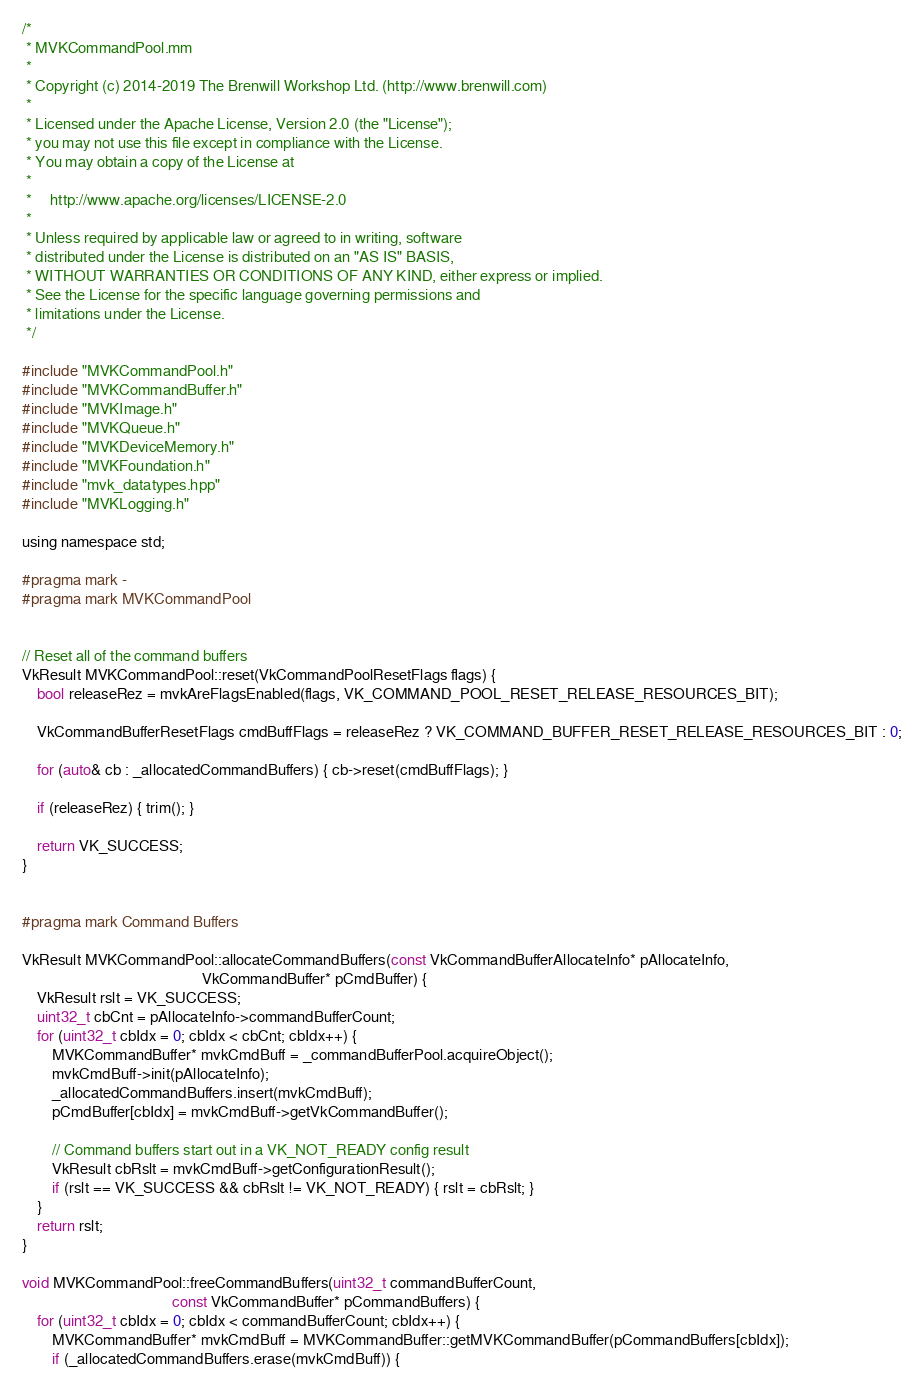<code> <loc_0><loc_0><loc_500><loc_500><_ObjectiveC_>/*
 * MVKCommandPool.mm
 *
 * Copyright (c) 2014-2019 The Brenwill Workshop Ltd. (http://www.brenwill.com)
 *
 * Licensed under the Apache License, Version 2.0 (the "License");
 * you may not use this file except in compliance with the License.
 * You may obtain a copy of the License at
 * 
 *     http://www.apache.org/licenses/LICENSE-2.0
 * 
 * Unless required by applicable law or agreed to in writing, software
 * distributed under the License is distributed on an "AS IS" BASIS,
 * WITHOUT WARRANTIES OR CONDITIONS OF ANY KIND, either express or implied.
 * See the License for the specific language governing permissions and
 * limitations under the License.
 */

#include "MVKCommandPool.h"
#include "MVKCommandBuffer.h"
#include "MVKImage.h"
#include "MVKQueue.h"
#include "MVKDeviceMemory.h"
#include "MVKFoundation.h"
#include "mvk_datatypes.hpp"
#include "MVKLogging.h"

using namespace std;

#pragma mark -
#pragma mark MVKCommandPool


// Reset all of the command buffers
VkResult MVKCommandPool::reset(VkCommandPoolResetFlags flags) {
	bool releaseRez = mvkAreFlagsEnabled(flags, VK_COMMAND_POOL_RESET_RELEASE_RESOURCES_BIT);

	VkCommandBufferResetFlags cmdBuffFlags = releaseRez ? VK_COMMAND_BUFFER_RESET_RELEASE_RESOURCES_BIT : 0;

	for (auto& cb : _allocatedCommandBuffers) { cb->reset(cmdBuffFlags); }

	if (releaseRez) { trim(); }

	return VK_SUCCESS;
}


#pragma mark Command Buffers

VkResult MVKCommandPool::allocateCommandBuffers(const VkCommandBufferAllocateInfo* pAllocateInfo,
												VkCommandBuffer* pCmdBuffer) {
	VkResult rslt = VK_SUCCESS;
	uint32_t cbCnt = pAllocateInfo->commandBufferCount;
	for (uint32_t cbIdx = 0; cbIdx < cbCnt; cbIdx++) {
		MVKCommandBuffer* mvkCmdBuff = _commandBufferPool.acquireObject();
		mvkCmdBuff->init(pAllocateInfo);
		_allocatedCommandBuffers.insert(mvkCmdBuff);
        pCmdBuffer[cbIdx] = mvkCmdBuff->getVkCommandBuffer();

		// Command buffers start out in a VK_NOT_READY config result
		VkResult cbRslt = mvkCmdBuff->getConfigurationResult();
		if (rslt == VK_SUCCESS && cbRslt != VK_NOT_READY) { rslt = cbRslt; }
	}
	return rslt;
}

void MVKCommandPool::freeCommandBuffers(uint32_t commandBufferCount,
										const VkCommandBuffer* pCommandBuffers) {
	for (uint32_t cbIdx = 0; cbIdx < commandBufferCount; cbIdx++) {
		MVKCommandBuffer* mvkCmdBuff = MVKCommandBuffer::getMVKCommandBuffer(pCommandBuffers[cbIdx]);
		if (_allocatedCommandBuffers.erase(mvkCmdBuff)) {</code> 